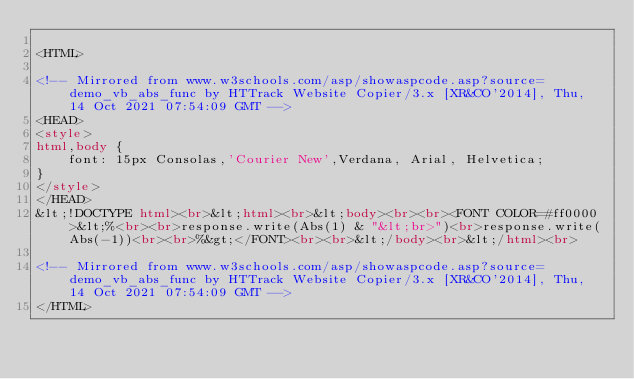Convert code to text. <code><loc_0><loc_0><loc_500><loc_500><_HTML_>
<HTML>

<!-- Mirrored from www.w3schools.com/asp/showaspcode.asp?source=demo_vb_abs_func by HTTrack Website Copier/3.x [XR&CO'2014], Thu, 14 Oct 2021 07:54:09 GMT -->
<HEAD>
<style>
html,body {
    font: 15px Consolas,'Courier New',Verdana, Arial, Helvetica;
}
</style>
</HEAD>
&lt;!DOCTYPE html><br>&lt;html><br>&lt;body><br><br><FONT COLOR=#ff0000>&lt;%<br><br>response.write(Abs(1) & "&lt;br>")<br>response.write(Abs(-1))<br><br>%&gt;</FONT><br><br>&lt;/body><br>&lt;/html><br>

<!-- Mirrored from www.w3schools.com/asp/showaspcode.asp?source=demo_vb_abs_func by HTTrack Website Copier/3.x [XR&CO'2014], Thu, 14 Oct 2021 07:54:09 GMT -->
</HTML>
</code> 